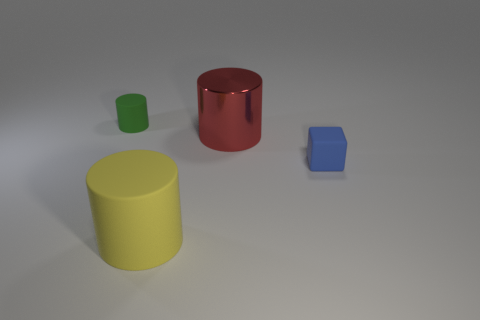Do the yellow matte thing in front of the large red cylinder and the cylinder on the right side of the big yellow thing have the same size?
Provide a succinct answer. Yes. How many things are either tiny brown matte cylinders or matte objects?
Ensure brevity in your answer.  3. Is there a large matte thing of the same shape as the big shiny thing?
Your answer should be compact. Yes. Is the number of blocks less than the number of large cylinders?
Provide a succinct answer. Yes. Is the yellow matte object the same shape as the green matte thing?
Provide a succinct answer. Yes. How many objects are tiny green matte cylinders or small rubber things that are in front of the large red shiny object?
Offer a terse response. 2. How many shiny objects are there?
Your answer should be compact. 1. Is there a blue rubber block that has the same size as the yellow rubber cylinder?
Keep it short and to the point. No. Is the number of blue rubber blocks that are left of the yellow rubber cylinder less than the number of big rubber objects?
Offer a very short reply. Yes. Is the size of the metal object the same as the green object?
Keep it short and to the point. No. 